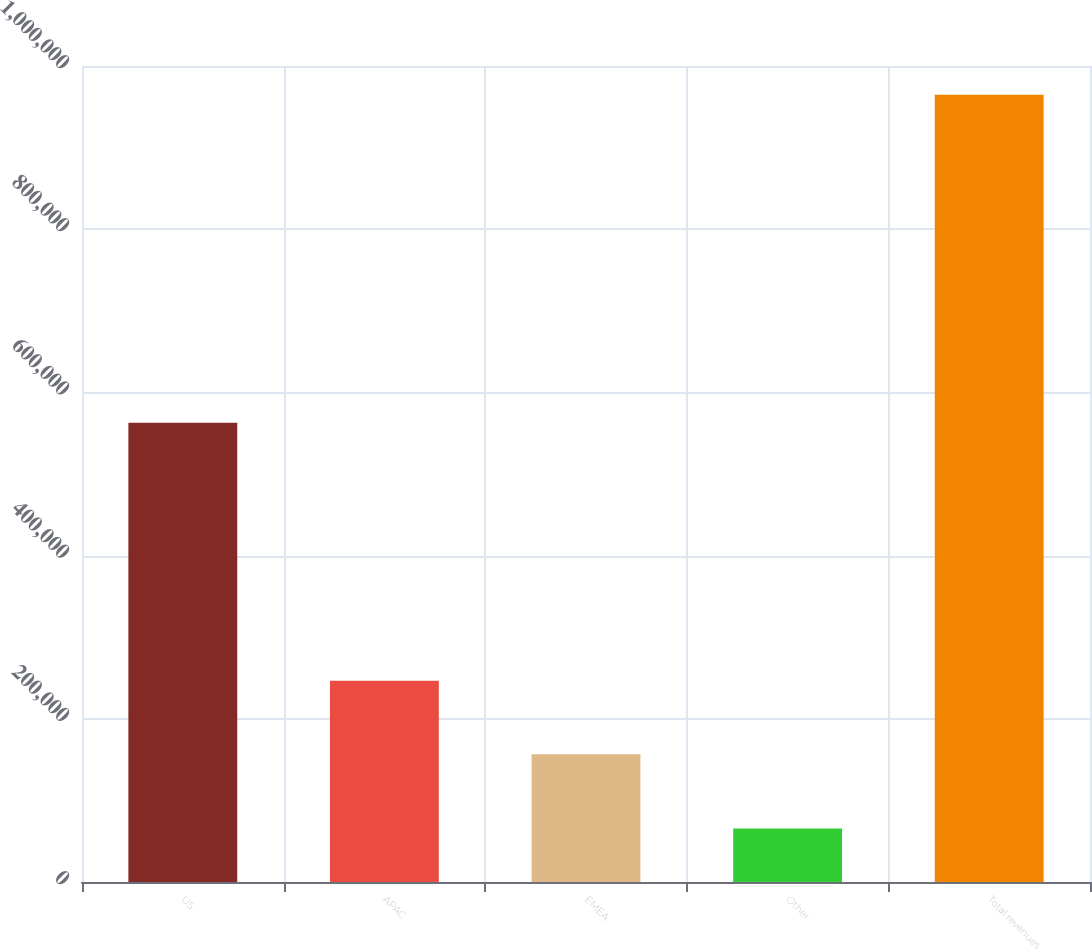Convert chart to OTSL. <chart><loc_0><loc_0><loc_500><loc_500><bar_chart><fcel>US<fcel>APAC<fcel>EMEA<fcel>Other<fcel>Total revenues<nl><fcel>562785<fcel>246619<fcel>156694<fcel>65496<fcel>964748<nl></chart> 